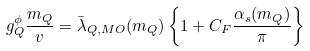Convert formula to latex. <formula><loc_0><loc_0><loc_500><loc_500>g _ { Q } ^ { \phi } \frac { m _ { Q } } { v } = \bar { \lambda } _ { Q , M O } ( m _ { Q } ) \left \{ 1 + C _ { F } \frac { \alpha _ { s } ( m _ { Q } ) } { \pi } \right \}</formula> 